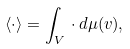<formula> <loc_0><loc_0><loc_500><loc_500>\langle \cdot \rangle = \int _ { V } \, \cdot \, d \mu ( v ) ,</formula> 